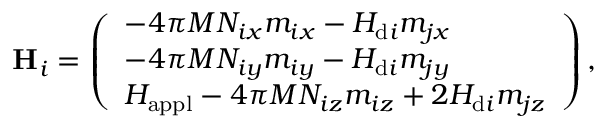<formula> <loc_0><loc_0><loc_500><loc_500>H _ { i } = \left ( \begin{array} { l } { - 4 \pi M N _ { i x } m _ { i x } - H _ { d i } m _ { j x } } \\ { - 4 \pi M N _ { i y } m _ { i y } - H _ { d i } m _ { j y } } \\ { H _ { a p p l } - 4 \pi M N _ { i z } m _ { i z } + 2 H _ { d i } m _ { j z } } \end{array} \right ) ,</formula> 